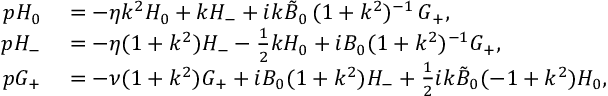<formula> <loc_0><loc_0><loc_500><loc_500>\begin{array} { r l } { p H _ { 0 } } & = - \eta k ^ { 2 } H _ { 0 } + k H _ { - } + i k \tilde { B } _ { 0 } \, ( 1 + k ^ { 2 } ) ^ { - 1 } \, G _ { + } , } \\ { p H _ { - } } & = - \eta ( 1 + k ^ { 2 } ) H _ { - } - \frac { 1 } { 2 } k H _ { 0 } + i B _ { 0 } ( 1 + k ^ { 2 } ) ^ { - 1 } G _ { + } , } \\ { p G _ { + } } & = - \nu ( 1 + k ^ { 2 } ) G _ { + } + i B _ { 0 } ( 1 + k ^ { 2 } ) H _ { - } + \frac { 1 } { 2 } { i k \tilde { B } _ { 0 } } ( - 1 + k ^ { 2 } ) H _ { 0 } , } \end{array}</formula> 